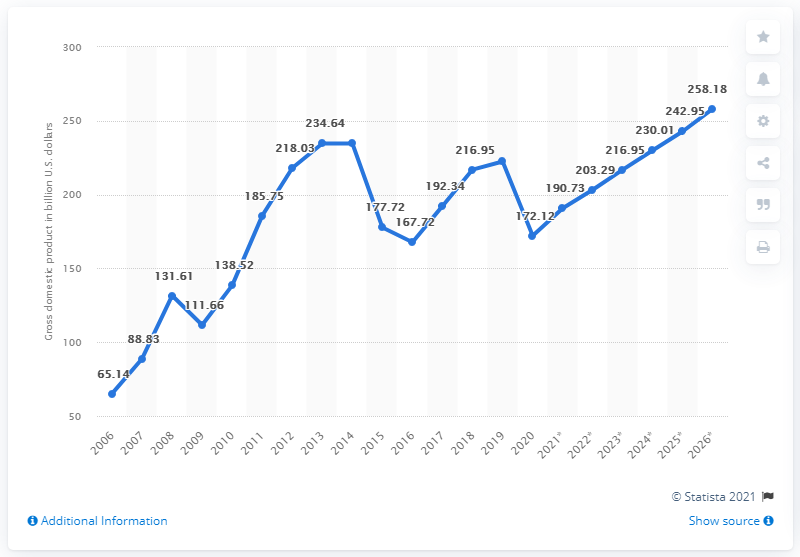What might have caused the fluctuations in Iraq's GDP as depicted in the graph? The fluctuations in Iraq's GDP could be attributed to a variety of factors, including changes in global oil prices as Iraq's economy is heavily dependent on oil exports, internal political stability, security conditions, and external economic conditions. For example, the decline in 2014 coincides with the fall of oil prices and the rise of conflicts in certain regions of Iraq. 